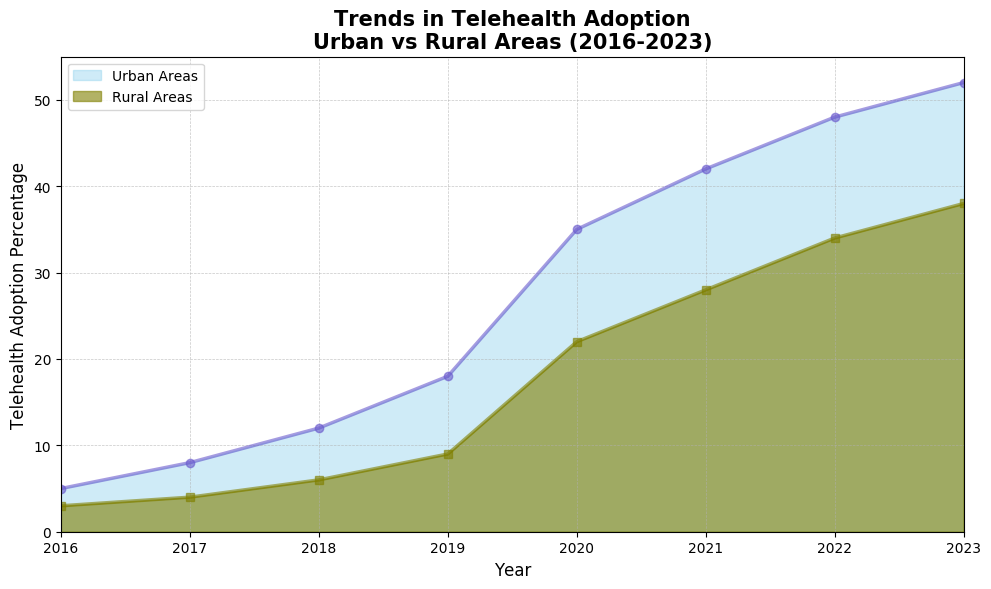What is the trend of telehealth adoption in urban areas from 2016 to 2023? By observing the line representing urban telehealth adoption (color: Slateblue) on the area chart, it starts at 5% in 2016 and increases steadily to 52% by 2023.
Answer: Increasing trend What was the telehealth adoption percentage difference between rural and urban areas in 2020? Urban areas had a 35% adoption rate in 2020, while rural areas had 22%. The difference is calculated as 35% - 22% = 13%.
Answer: 13% Which year had the highest gap in telehealth adoption percentages between urban and rural areas? By comparing the gaps year by year, we observe the largest gap in 2023 with urban areas at 52% and rural areas at 38%, resulting in a difference of 14%.
Answer: 2023 What was the overall percentage increase in telehealth adoption for rural areas from 2016 to 2023? Rural areas started at 3% in 2016 and grew to 38% by 2023. The overall increase is calculated as 38% - 3% = 35%.
Answer: 35% How did the adoption rates in urban and rural areas compare in 2021? In 2021, urban adoption was at 42% and rural adoption was at 28%. Urban adoption was 14 percentage points higher than rural adoption.
Answer: Urban was 14% higher What is the percentage increase in urban telehealth adoption from 2019 to 2020? Urban telehealth adoption was 18% in 2019 and increased to 35% in 2020. The percentage increase is calculated by (35 - 18) / 18 * 100% = 94.44%.
Answer: 94.44% Examining the trend, which type of area showed the least telehealth adoption in 2018? The area chart shows that in 2018, rural areas had a lower adoption rate (6%) compared to urban areas (12%).
Answer: Rural areas Were there any years where both urban and rural areas experienced similar growth rates? In 2017 and 2018, urban adoption increased from 8% to 12% (4% increase) and rural from 4% to 6% (2% increase), both doubling their rates from 2016.
Answer: Yes, 2017 and 2018 How much more did urban telehealth adoption increase compared to rural adoption during 2022? In 2022, urban adoption increased to 48% from 42% in the previous year, a 6% increase. Rural adoption increased to 34% from 28%, also a 6% increase. The difference is 6% - 6% = 0%.
Answer: Same increase 